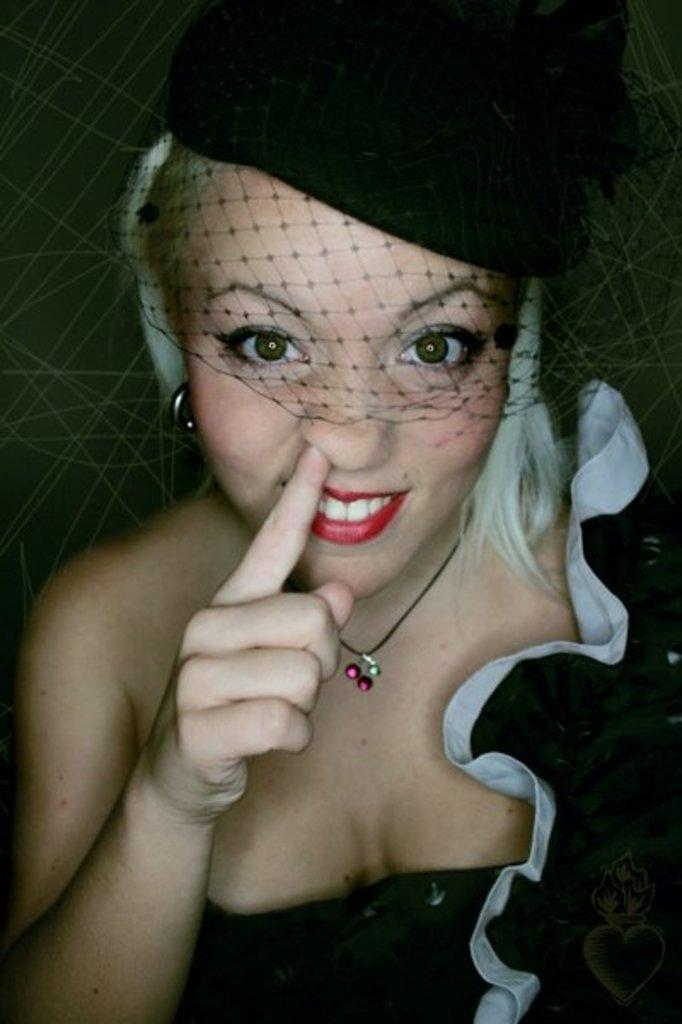Who is the main subject in the picture? There is a woman in the picture. What is the woman wearing in the image? The woman is wearing a white and black color dress and a black color cap on her head. What type of legal advice is the woman providing in the image? There is no indication in the image that the woman is providing legal advice or acting as a lawyer. 